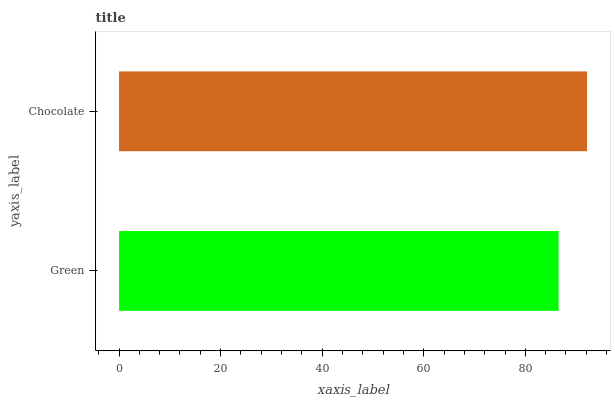Is Green the minimum?
Answer yes or no. Yes. Is Chocolate the maximum?
Answer yes or no. Yes. Is Chocolate the minimum?
Answer yes or no. No. Is Chocolate greater than Green?
Answer yes or no. Yes. Is Green less than Chocolate?
Answer yes or no. Yes. Is Green greater than Chocolate?
Answer yes or no. No. Is Chocolate less than Green?
Answer yes or no. No. Is Chocolate the high median?
Answer yes or no. Yes. Is Green the low median?
Answer yes or no. Yes. Is Green the high median?
Answer yes or no. No. Is Chocolate the low median?
Answer yes or no. No. 